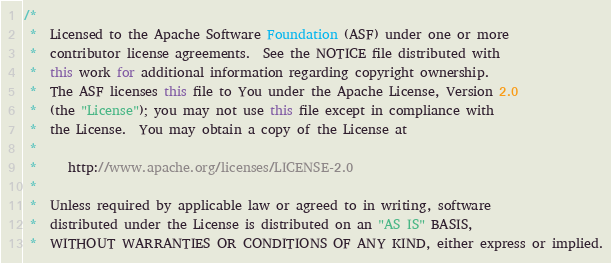<code> <loc_0><loc_0><loc_500><loc_500><_Java_>/*
 *  Licensed to the Apache Software Foundation (ASF) under one or more
 *  contributor license agreements.  See the NOTICE file distributed with
 *  this work for additional information regarding copyright ownership.
 *  The ASF licenses this file to You under the Apache License, Version 2.0
 *  (the "License"); you may not use this file except in compliance with
 *  the License.  You may obtain a copy of the License at
 *
 *     http://www.apache.org/licenses/LICENSE-2.0
 *
 *  Unless required by applicable law or agreed to in writing, software
 *  distributed under the License is distributed on an "AS IS" BASIS,
 *  WITHOUT WARRANTIES OR CONDITIONS OF ANY KIND, either express or implied.</code> 